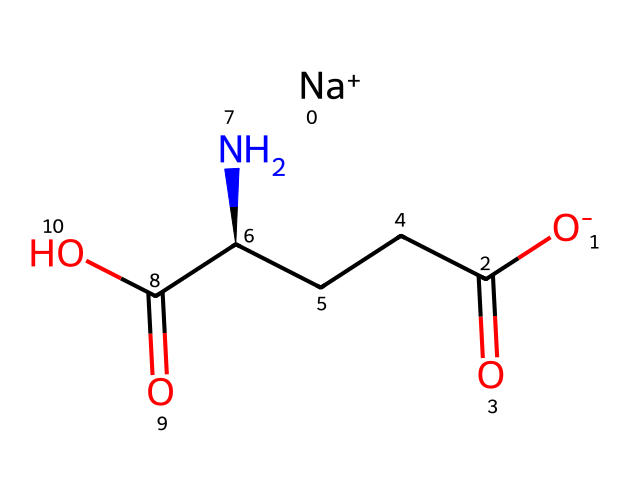What type of chemical is MSG? The SMILES representation indicates that MSG is a monosodium salt of glutamic acid, showcasing both organic and ionic characteristics.
Answer: monosodium salt How many carbon atoms are present in MSG? By analyzing the structure derived from the SMILES, there are five carbon atoms marked as 'C' in the backbone of the molecule.
Answer: five What is the charge of the sodium ion in MSG? The notation "[Na+]" specifies that the sodium ion carries a +1 charge as indicated by the plus sign in the SMILES notation.
Answer: +1 What functional groups are present in MSG? Observing the structure shows that MSG contains two carboxylic acid groups (-COOH) and an amino group (-NH2), which define it as an amino acid with acidic properties.
Answer: carboxylic acid and amino What makes MSG a flavor enhancer? The structure includes a unique arrangement of amino and carboxylic groups, which interact with taste receptors to enhance umami flavor, giving MSG its distinct taste profile.
Answer: umami How many double bonds are present in the MSG structure? Upon reviewing the structure derived from the SMILES, there are two double bonds indicated with the '=' sign, specifically within the carboxylic acid functional groups.
Answer: two What is the significance of the stereochemistry in MSG? The notation "[C@H]" denotes that there is a chiral center in the structure, which indicates that the molecule can exist in two enantiomeric forms affecting its biological activity.
Answer: chiral center 